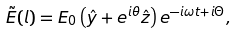<formula> <loc_0><loc_0><loc_500><loc_500>\tilde { E } ( l ) = E _ { 0 } \left ( \hat { y } + e ^ { i \theta } \hat { z } \right ) e ^ { - i \omega t + i \Theta } ,</formula> 